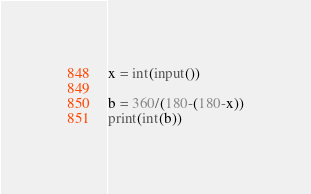Convert code to text. <code><loc_0><loc_0><loc_500><loc_500><_Python_>x = int(input())

b = 360/(180-(180-x))
print(int(b))
</code> 